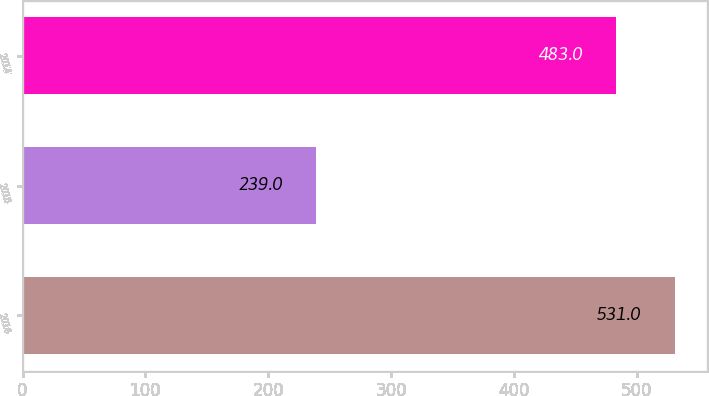<chart> <loc_0><loc_0><loc_500><loc_500><bar_chart><fcel>2016<fcel>2015<fcel>2014<nl><fcel>531<fcel>239<fcel>483<nl></chart> 